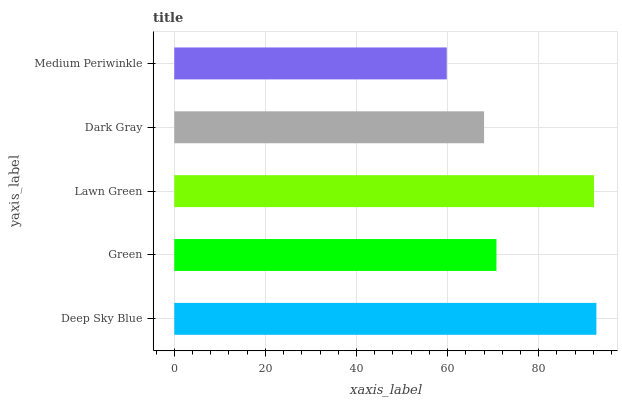Is Medium Periwinkle the minimum?
Answer yes or no. Yes. Is Deep Sky Blue the maximum?
Answer yes or no. Yes. Is Green the minimum?
Answer yes or no. No. Is Green the maximum?
Answer yes or no. No. Is Deep Sky Blue greater than Green?
Answer yes or no. Yes. Is Green less than Deep Sky Blue?
Answer yes or no. Yes. Is Green greater than Deep Sky Blue?
Answer yes or no. No. Is Deep Sky Blue less than Green?
Answer yes or no. No. Is Green the high median?
Answer yes or no. Yes. Is Green the low median?
Answer yes or no. Yes. Is Medium Periwinkle the high median?
Answer yes or no. No. Is Dark Gray the low median?
Answer yes or no. No. 